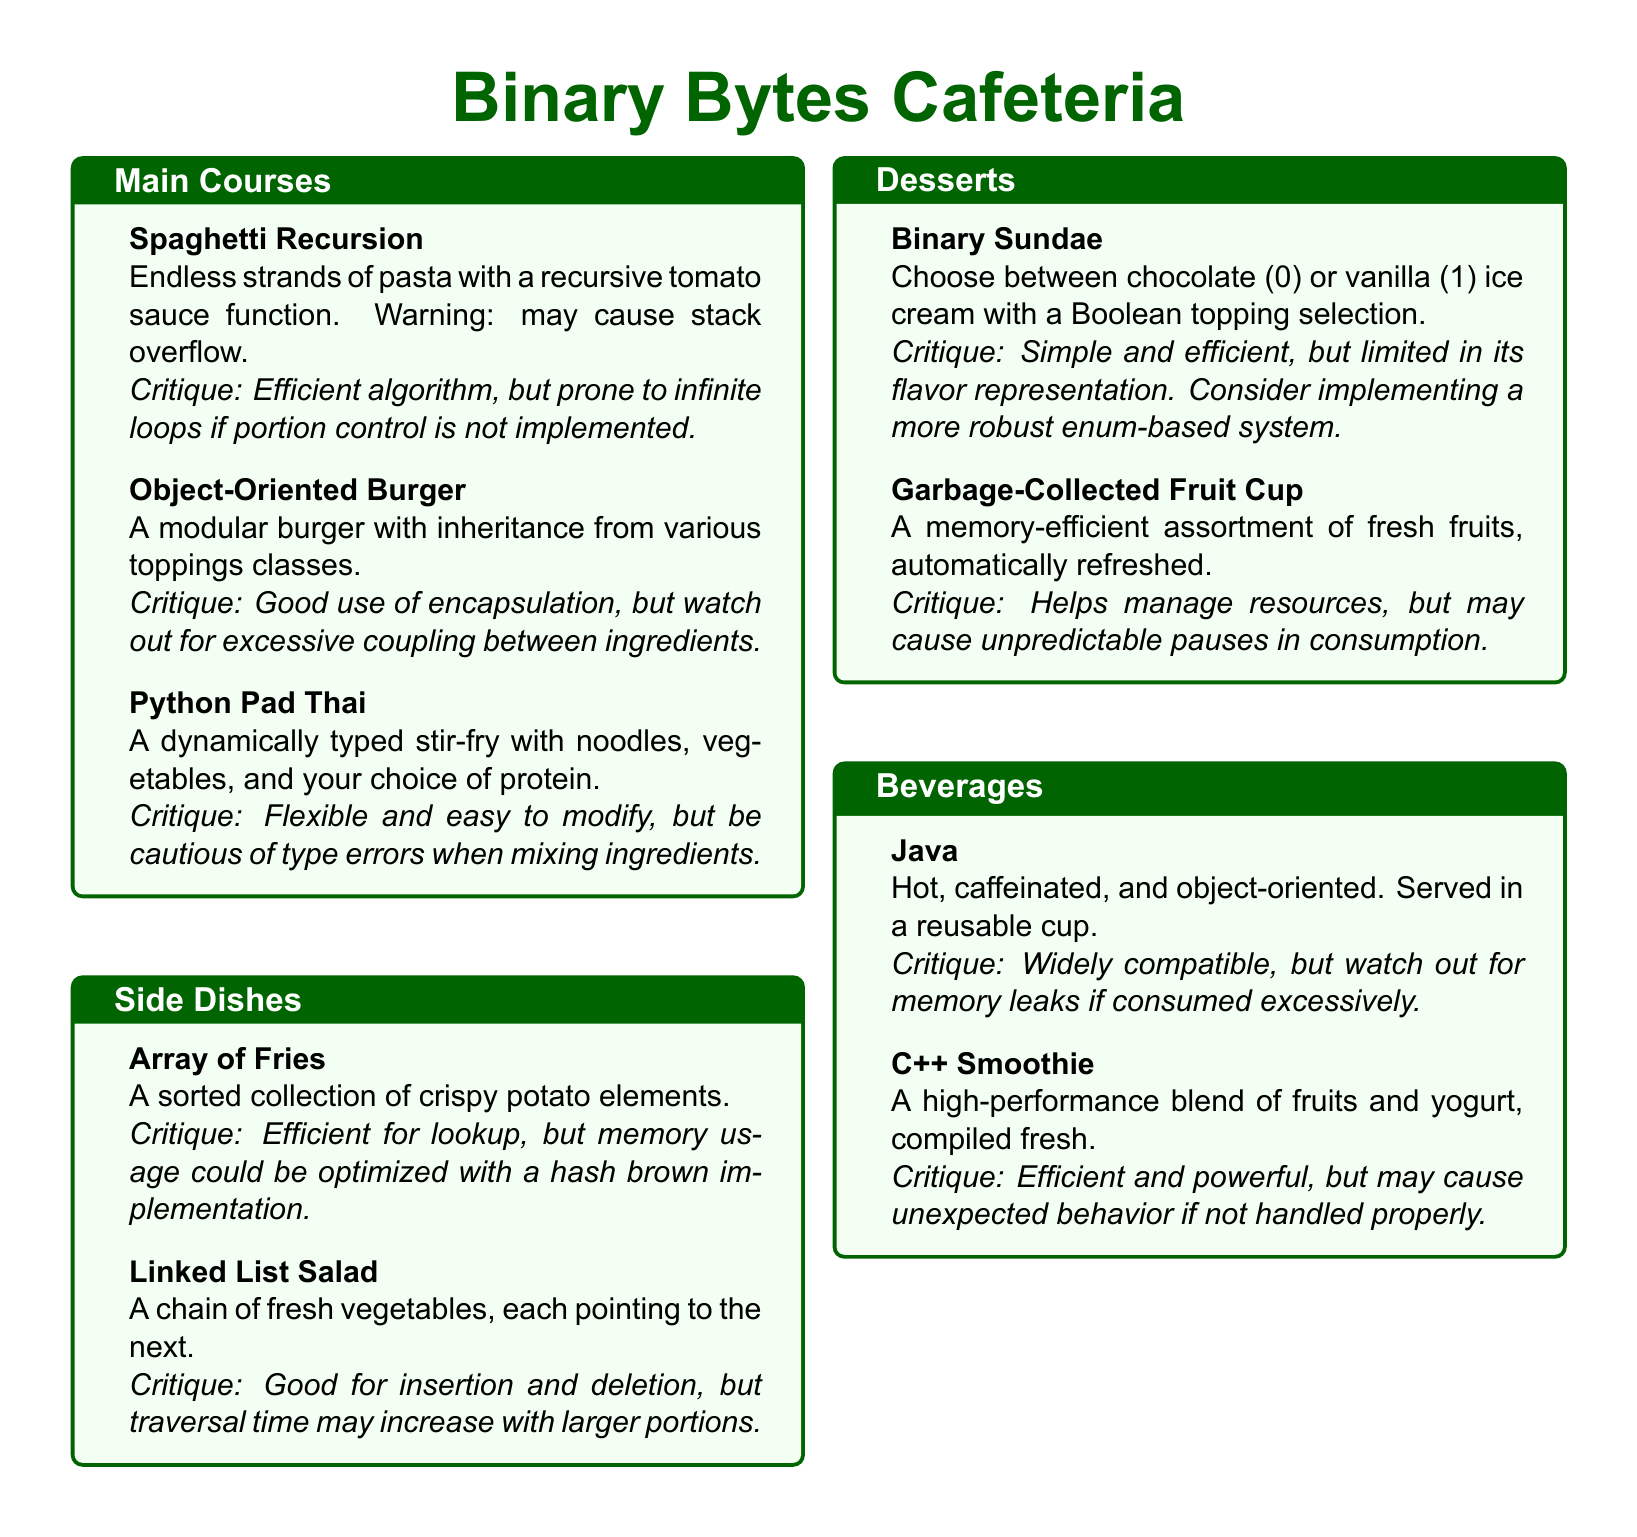What are the main course options? The document lists three main course options: Spaghetti Recursion, Object-Oriented Burger, and Python Pad Thai.
Answer: Spaghetti Recursion, Object-Oriented Burger, Python Pad Thai What is the critique for the Binary Sundae? The critique states that while the Binary Sundae is simple and efficient, its flavor representation is limited.
Answer: Limited in its flavor representation What type of dish is Linked List Salad? The Linked List Salad is categorized as a Side Dish in the document.
Answer: Side Dish How many desserts are listed in the menu? The document provides a total of two dessert options: Binary Sundae and Garbage-Collected Fruit Cup.
Answer: Two What beverages are offered? The menu lists two beverage options: Java and C++ Smoothie.
Answer: Java, C++ Smoothie What is a characteristic of the Object-Oriented Burger? The Object-Oriented Burger is noted for its modularity and inheritance from various toppings classes.
Answer: Modular burger with inheritance What is the problem with the Array of Fries? The critique mentions that while the Array of Fries is efficient for lookup, its memory usage could be optimized.
Answer: Memory usage could be optimized What is the recommended caution for Python Pad Thai? The critique warns to be cautious of type errors when mixing ingredients in the Python Pad Thai.
Answer: Cautious of type errors 